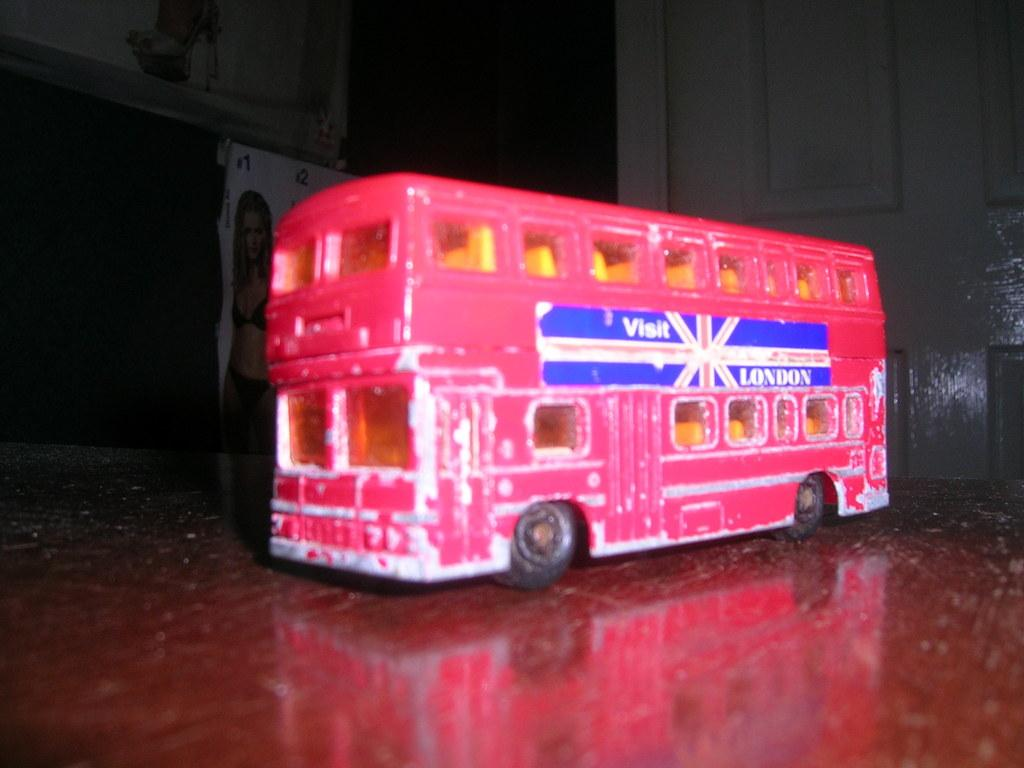What type of toy is on the table in the image? There is a toy bus on a table in the image. What is another feature visible in the image? There is a door visible in the image. What type of decorations are present in the image? There are posters in the image. How does the friend help with the payment in the image? There is no friend or payment present in the image. What shape is the toy bus in the image? The provided facts do not mention the shape of the toy bus, so it cannot be determined from the image. 